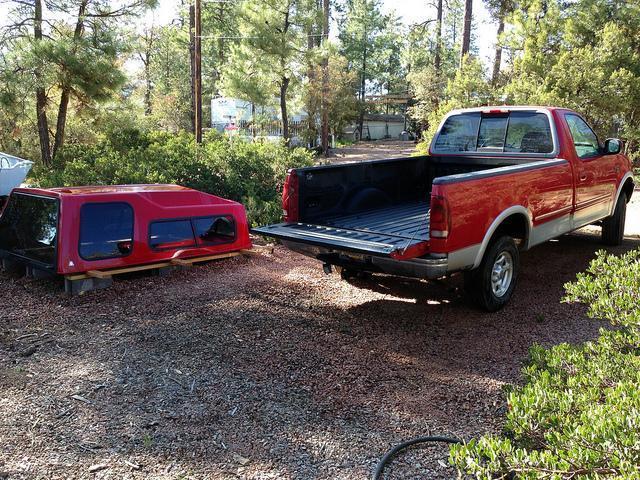How many people are wearing blue tops?
Give a very brief answer. 0. 